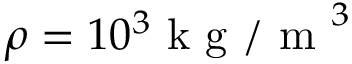Convert formula to latex. <formula><loc_0><loc_0><loc_500><loc_500>\rho = 1 0 ^ { 3 } k g / m ^ { 3 }</formula> 